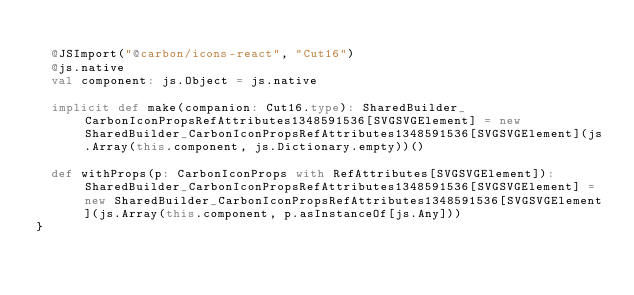Convert code to text. <code><loc_0><loc_0><loc_500><loc_500><_Scala_>  
  @JSImport("@carbon/icons-react", "Cut16")
  @js.native
  val component: js.Object = js.native
  
  implicit def make(companion: Cut16.type): SharedBuilder_CarbonIconPropsRefAttributes1348591536[SVGSVGElement] = new SharedBuilder_CarbonIconPropsRefAttributes1348591536[SVGSVGElement](js.Array(this.component, js.Dictionary.empty))()
  
  def withProps(p: CarbonIconProps with RefAttributes[SVGSVGElement]): SharedBuilder_CarbonIconPropsRefAttributes1348591536[SVGSVGElement] = new SharedBuilder_CarbonIconPropsRefAttributes1348591536[SVGSVGElement](js.Array(this.component, p.asInstanceOf[js.Any]))
}
</code> 